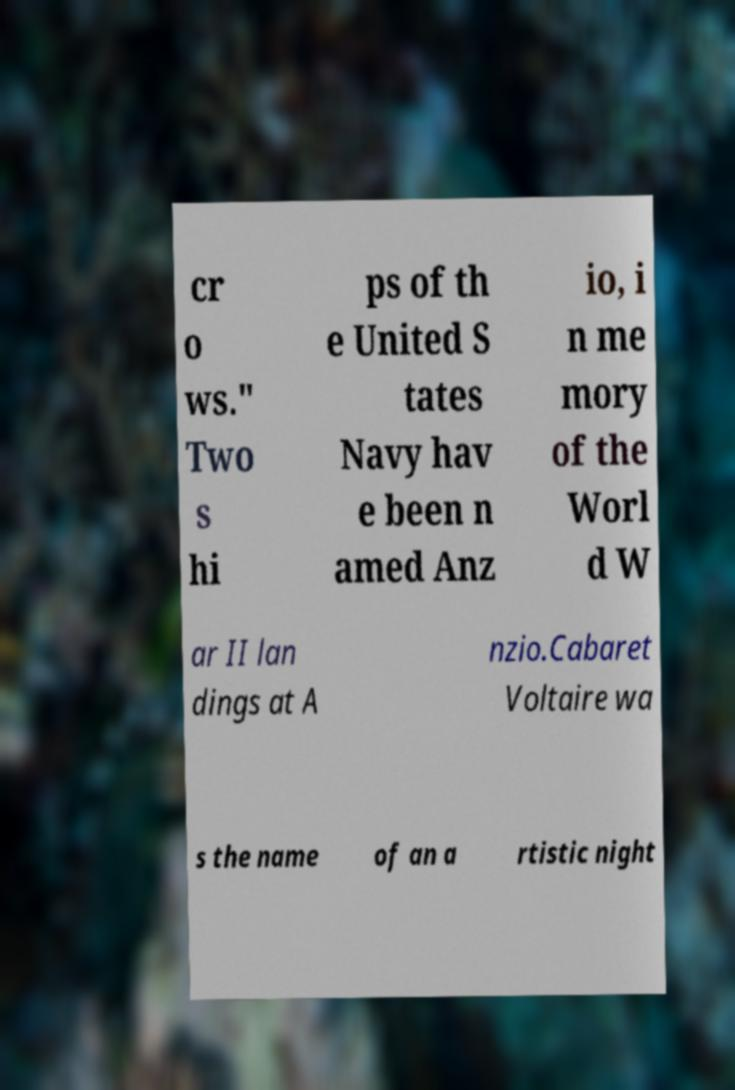Can you accurately transcribe the text from the provided image for me? cr o ws." Two s hi ps of th e United S tates Navy hav e been n amed Anz io, i n me mory of the Worl d W ar II lan dings at A nzio.Cabaret Voltaire wa s the name of an a rtistic night 